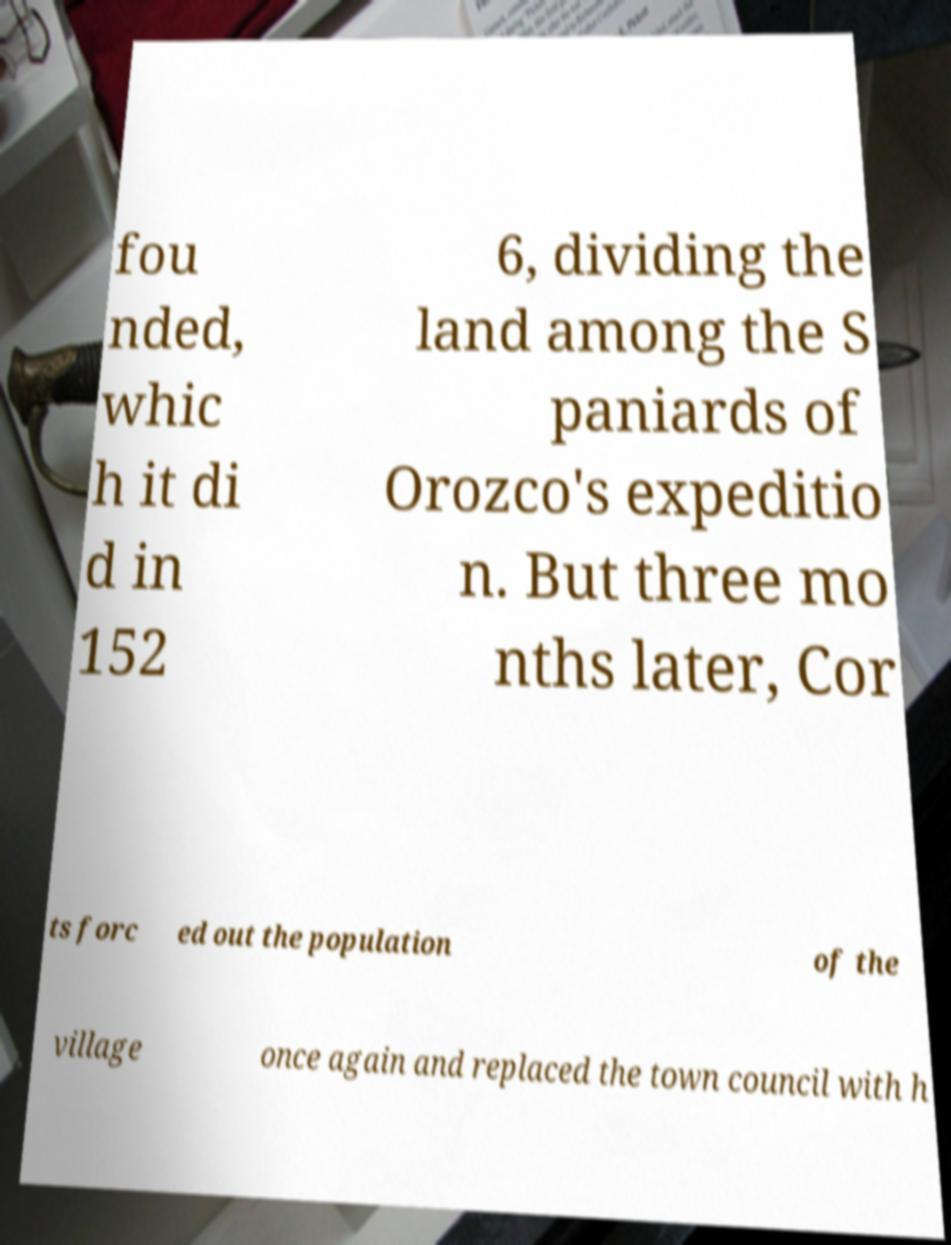Could you extract and type out the text from this image? fou nded, whic h it di d in 152 6, dividing the land among the S paniards of Orozco's expeditio n. But three mo nths later, Cor ts forc ed out the population of the village once again and replaced the town council with h 